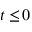Convert formula to latex. <formula><loc_0><loc_0><loc_500><loc_500>t \leq \, 0</formula> 